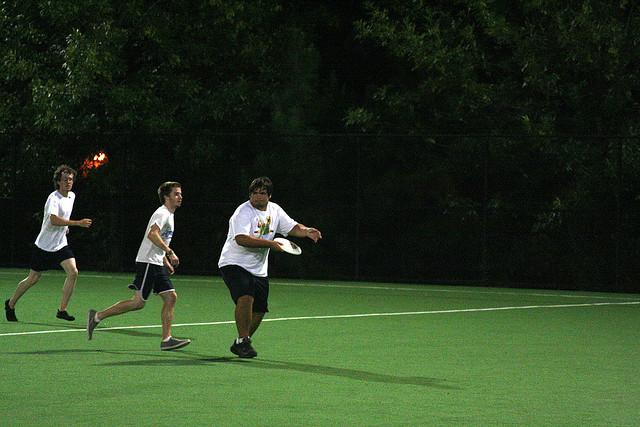Are these people wearing the same color shirts?
Keep it brief. Yes. How many people on the field?
Short answer required. 3. Are they on real grass?
Give a very brief answer. No. Are the men wearing pants?
Write a very short answer. No. What sport is this?
Quick response, please. Frisbee. What is the people doing?
Concise answer only. Playing frisbee. 